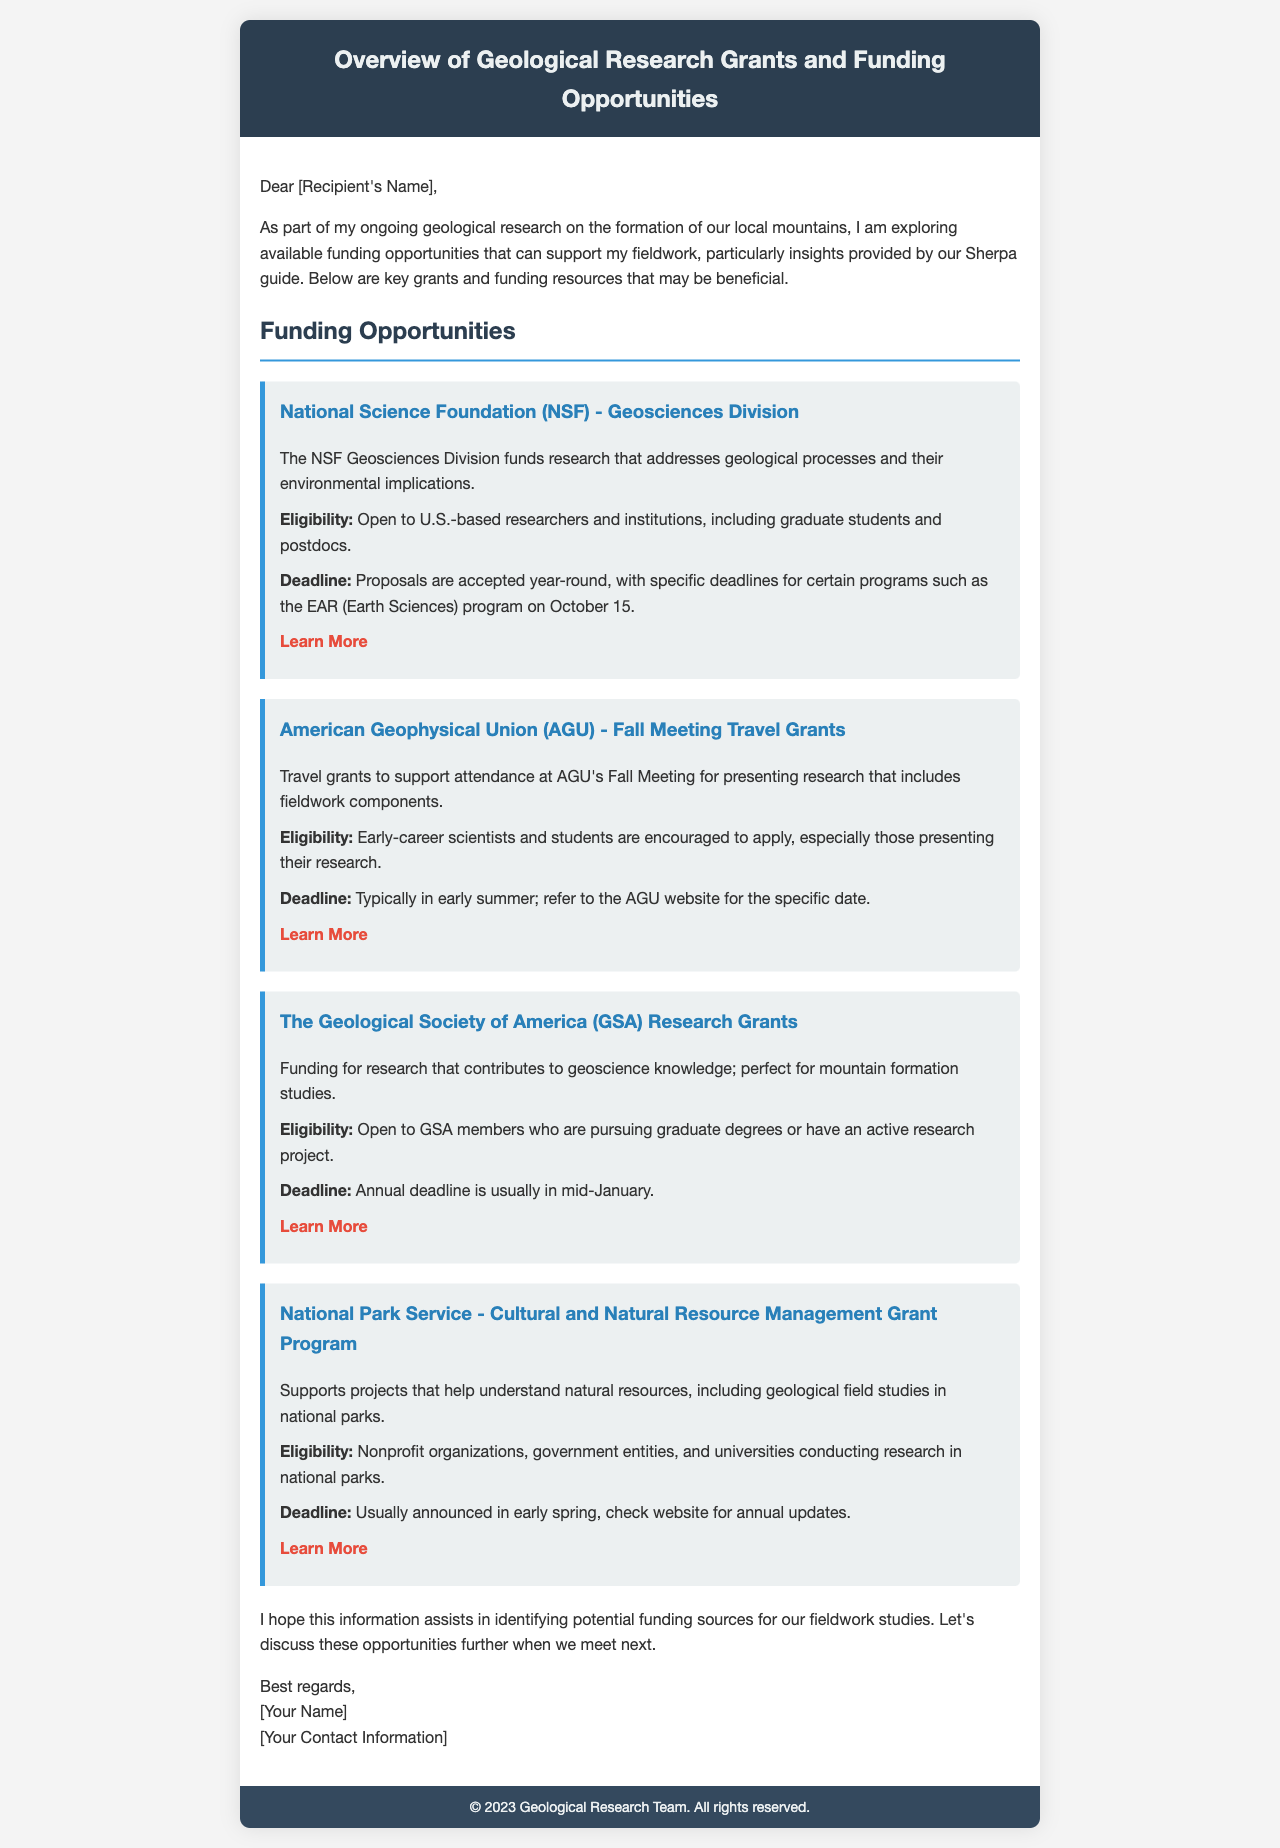What organization funds research addressing geological processes? The organization that funds this type of research is the National Science Foundation (NSF) through its Geosciences Division.
Answer: National Science Foundation (NSF) Who is eligible for the AGU Fall Meeting Travel Grants? The eligibility for these grants includes early-career scientists and students who present their research.
Answer: Early-career scientists and students What is the annual deadline for the GSA Research Grants? The GSA Research Grants have an annual deadline that is usually in mid-January.
Answer: Mid-January How often are NSF proposals accepted? Proposals for the NSF Geosciences Division are accepted year-round, but specific programs have deadlines.
Answer: Year-round Which grant supports projects in national parks? The grant that supports projects helping to understand natural resources in national parks is the National Park Service Cultural and Natural Resource Management Grant Program.
Answer: National Park Service Grant Program What is the typical deadline for AGU travel grants? The typical deadline for AGU travel grants is in early summer, with specific dates available on their website.
Answer: Early summer What type of projects does the National Park Service grant program support? The National Park Service grant program supports projects that include geological field studies in national parks.
Answer: Geological field studies What is a key focus for the Geological Society of America grants? The key focus for these grants is to fund research that contributes to geoscience knowledge, especially mountain formation studies.
Answer: Geoscience knowledge What additional context should be discussed when meeting next? The discussion should include the identified funding sources for fieldwork studies.
Answer: Funding sources for fieldwork studies 